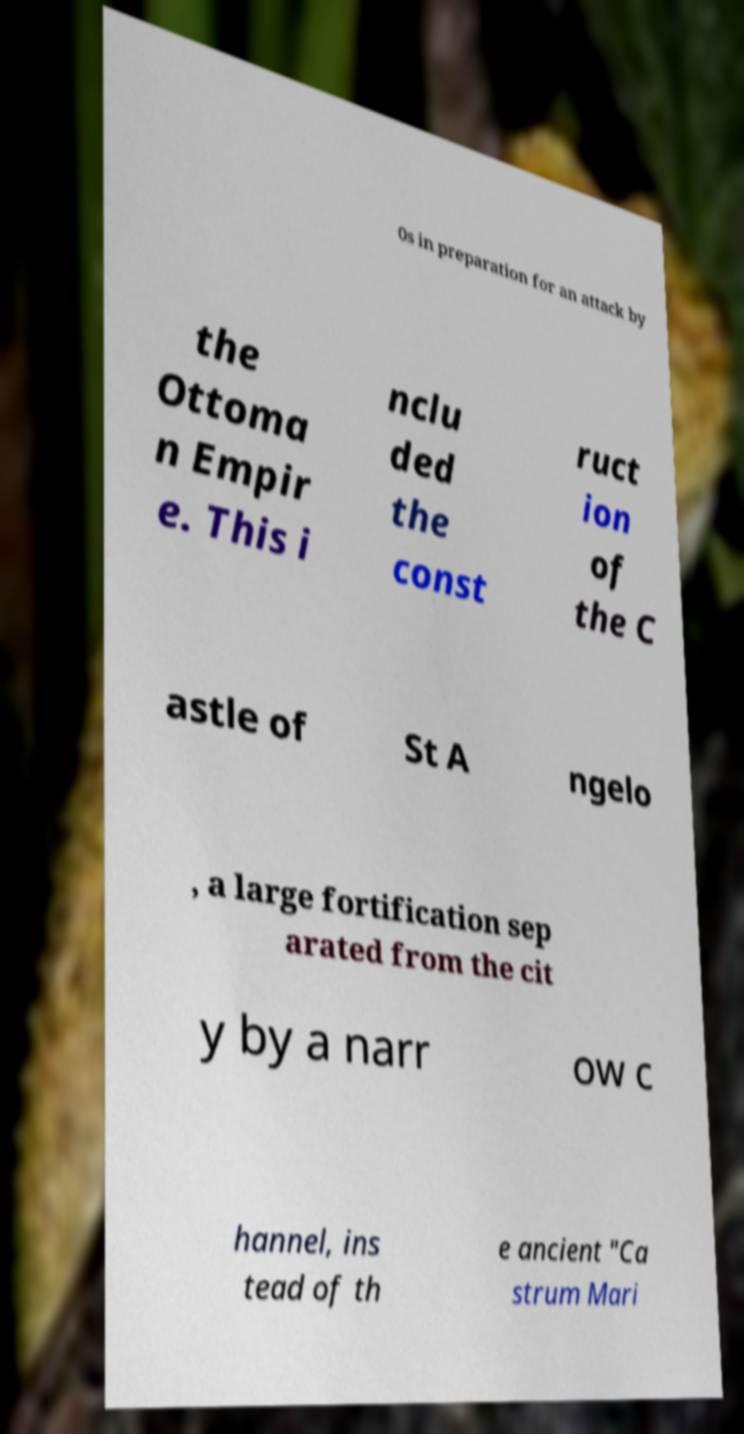Can you read and provide the text displayed in the image?This photo seems to have some interesting text. Can you extract and type it out for me? 0s in preparation for an attack by the Ottoma n Empir e. This i nclu ded the const ruct ion of the C astle of St A ngelo , a large fortification sep arated from the cit y by a narr ow c hannel, ins tead of th e ancient "Ca strum Mari 